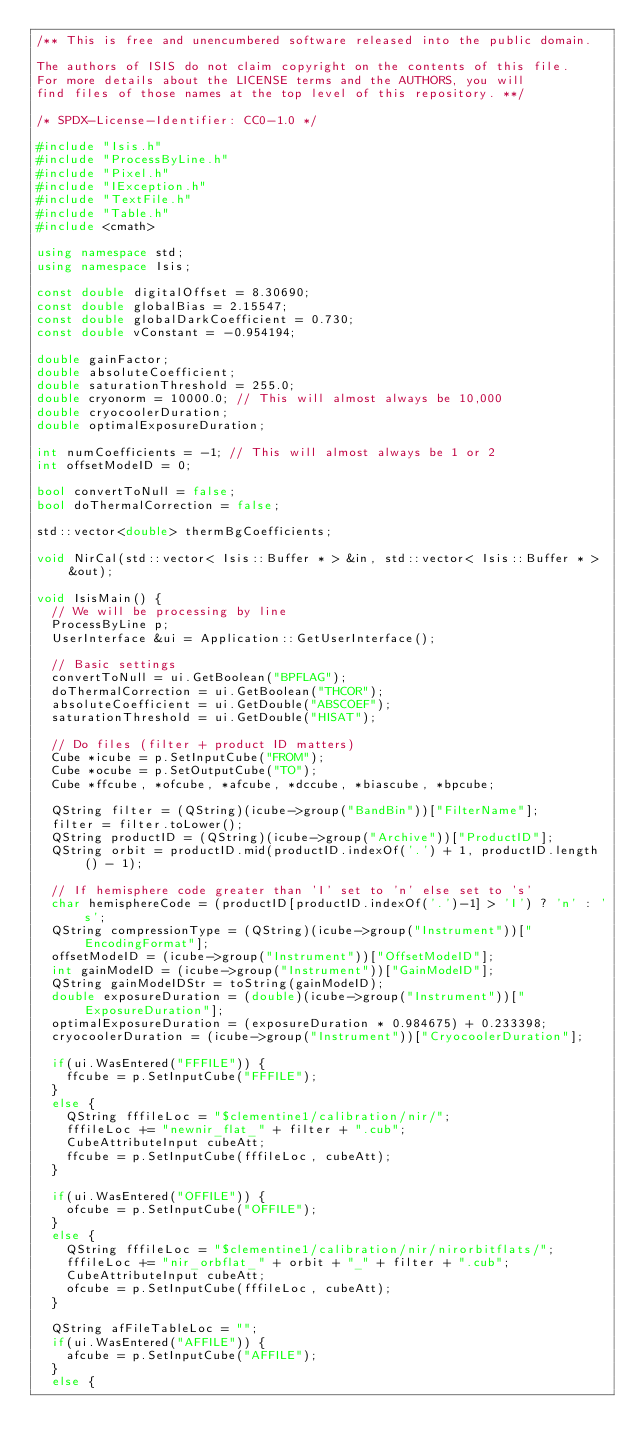Convert code to text. <code><loc_0><loc_0><loc_500><loc_500><_C++_>/** This is free and unencumbered software released into the public domain.

The authors of ISIS do not claim copyright on the contents of this file.
For more details about the LICENSE terms and the AUTHORS, you will
find files of those names at the top level of this repository. **/

/* SPDX-License-Identifier: CC0-1.0 */

#include "Isis.h"
#include "ProcessByLine.h"
#include "Pixel.h"
#include "IException.h"
#include "TextFile.h"
#include "Table.h"
#include <cmath>

using namespace std;
using namespace Isis;

const double digitalOffset = 8.30690;
const double globalBias = 2.15547;
const double globalDarkCoefficient = 0.730;
const double vConstant = -0.954194;

double gainFactor;
double absoluteCoefficient;
double saturationThreshold = 255.0;
double cryonorm = 10000.0; // This will almost always be 10,000
double cryocoolerDuration;
double optimalExposureDuration;

int numCoefficients = -1; // This will almost always be 1 or 2
int offsetModeID = 0;

bool convertToNull = false;
bool doThermalCorrection = false;

std::vector<double> thermBgCoefficients;

void NirCal(std::vector< Isis::Buffer * > &in, std::vector< Isis::Buffer * > &out);

void IsisMain() {
  // We will be processing by line
  ProcessByLine p;
  UserInterface &ui = Application::GetUserInterface();

  // Basic settings
  convertToNull = ui.GetBoolean("BPFLAG");
  doThermalCorrection = ui.GetBoolean("THCOR");
  absoluteCoefficient = ui.GetDouble("ABSCOEF");
  saturationThreshold = ui.GetDouble("HISAT");

  // Do files (filter + product ID matters)
  Cube *icube = p.SetInputCube("FROM");
  Cube *ocube = p.SetOutputCube("TO");
  Cube *ffcube, *ofcube, *afcube, *dccube, *biascube, *bpcube;

  QString filter = (QString)(icube->group("BandBin"))["FilterName"];
  filter = filter.toLower();
  QString productID = (QString)(icube->group("Archive"))["ProductID"];
  QString orbit = productID.mid(productID.indexOf('.') + 1, productID.length() - 1);

  // If hemisphere code greater than 'I' set to 'n' else set to 's'
  char hemisphereCode = (productID[productID.indexOf('.')-1] > 'I') ? 'n' : 's';
  QString compressionType = (QString)(icube->group("Instrument"))["EncodingFormat"];
  offsetModeID = (icube->group("Instrument"))["OffsetModeID"];
  int gainModeID = (icube->group("Instrument"))["GainModeID"];
  QString gainModeIDStr = toString(gainModeID);
  double exposureDuration = (double)(icube->group("Instrument"))["ExposureDuration"];
  optimalExposureDuration = (exposureDuration * 0.984675) + 0.233398;
  cryocoolerDuration = (icube->group("Instrument"))["CryocoolerDuration"];

  if(ui.WasEntered("FFFILE")) {
    ffcube = p.SetInputCube("FFFILE");
  }
  else {
    QString fffileLoc = "$clementine1/calibration/nir/";
    fffileLoc += "newnir_flat_" + filter + ".cub";
    CubeAttributeInput cubeAtt;
    ffcube = p.SetInputCube(fffileLoc, cubeAtt);
  }

  if(ui.WasEntered("OFFILE")) {
    ofcube = p.SetInputCube("OFFILE");
  }
  else {
    QString fffileLoc = "$clementine1/calibration/nir/nirorbitflats/";
    fffileLoc += "nir_orbflat_" + orbit + "_" + filter + ".cub";
    CubeAttributeInput cubeAtt;
    ofcube = p.SetInputCube(fffileLoc, cubeAtt);
  }

  QString afFileTableLoc = "";
  if(ui.WasEntered("AFFILE")) {
    afcube = p.SetInputCube("AFFILE");
  }
  else {</code> 